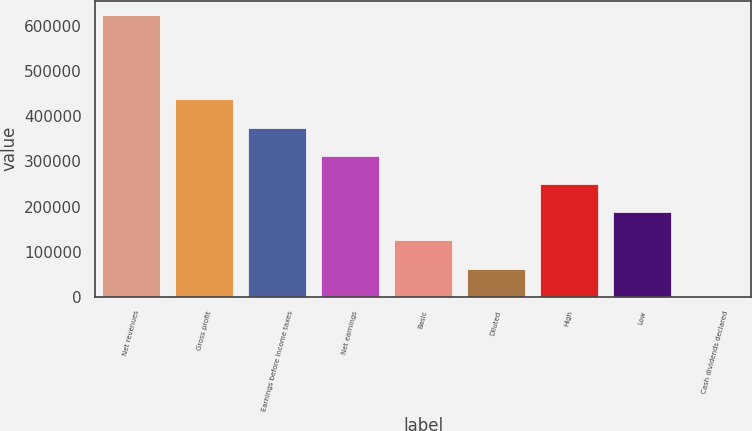<chart> <loc_0><loc_0><loc_500><loc_500><bar_chart><fcel>Net revenues<fcel>Gross profit<fcel>Earnings before income taxes<fcel>Net earnings<fcel>Basic<fcel>Diluted<fcel>High<fcel>Low<fcel>Cash dividends declared<nl><fcel>625267<fcel>437687<fcel>375160<fcel>312634<fcel>125054<fcel>62526.8<fcel>250107<fcel>187580<fcel>0.16<nl></chart> 